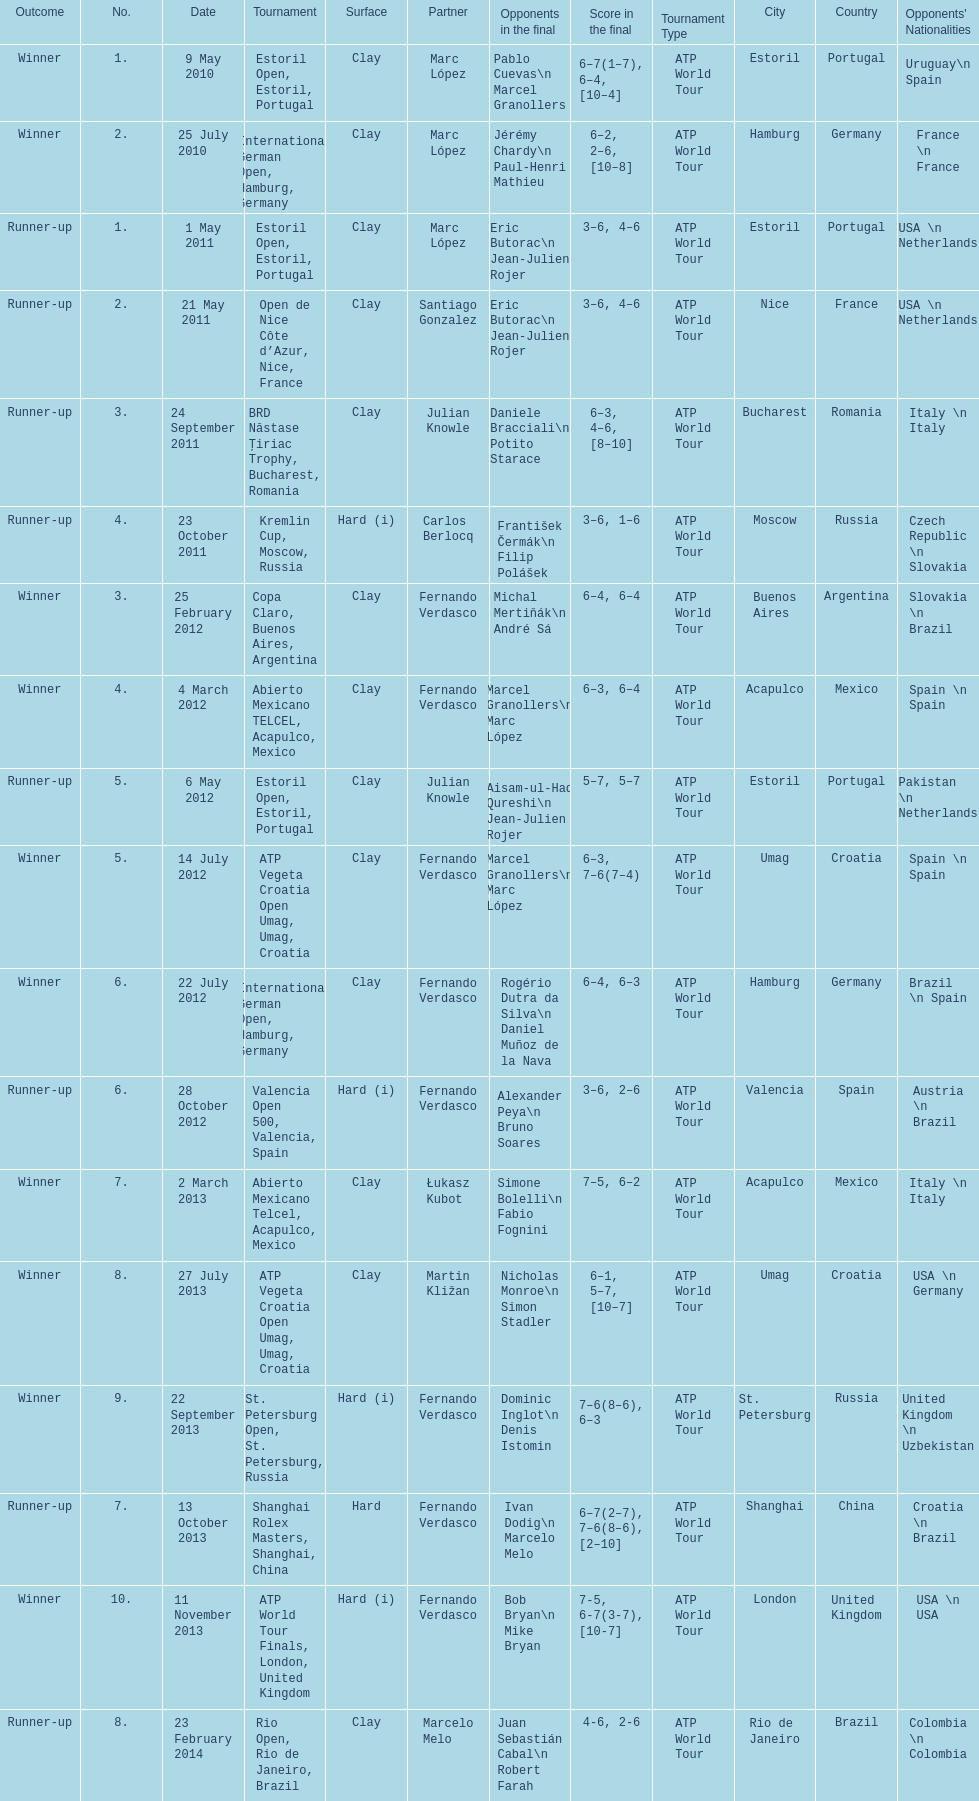What tournament was before the estoril open? Abierto Mexicano TELCEL, Acapulco, Mexico. 